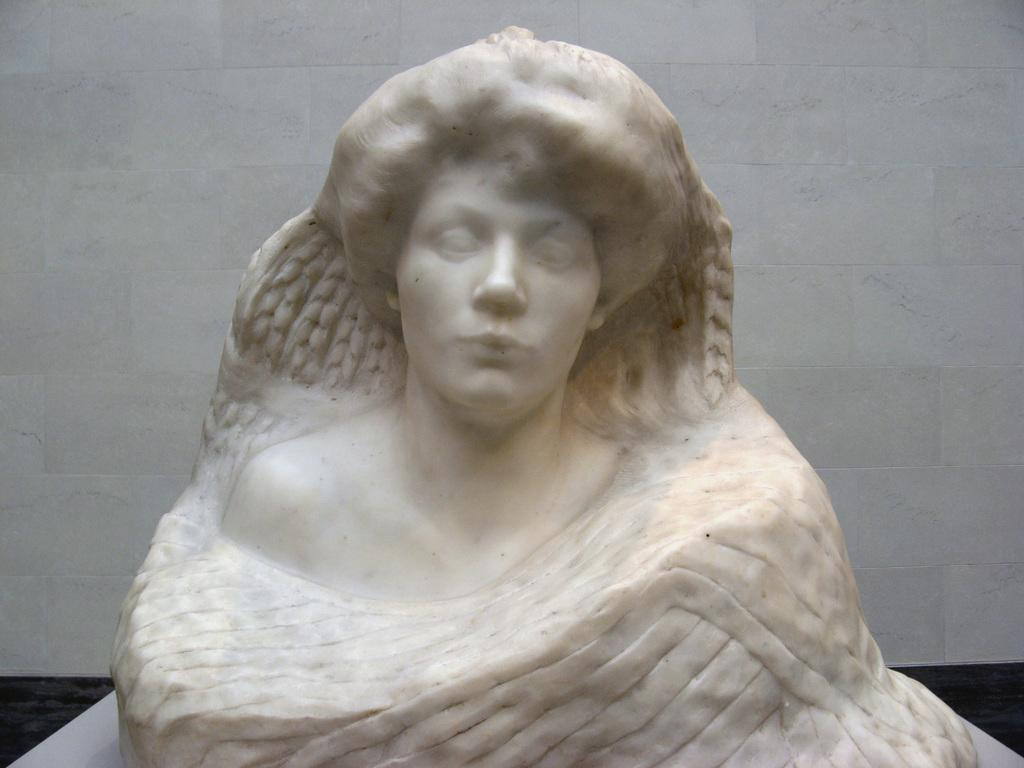What is the main subject in the middle of the image? There is a statue in the middle of the image. What can be seen in the background of the image? There is a wall in the background of the image. How many icicles are hanging from the statue in the image? There are no icicles present in the image; it features a statue and a wall in the background. What type of good-bye gesture can be seen from the statue in the image? There is no good-bye gesture present in the image, as it features a statue and a wall in the background. 